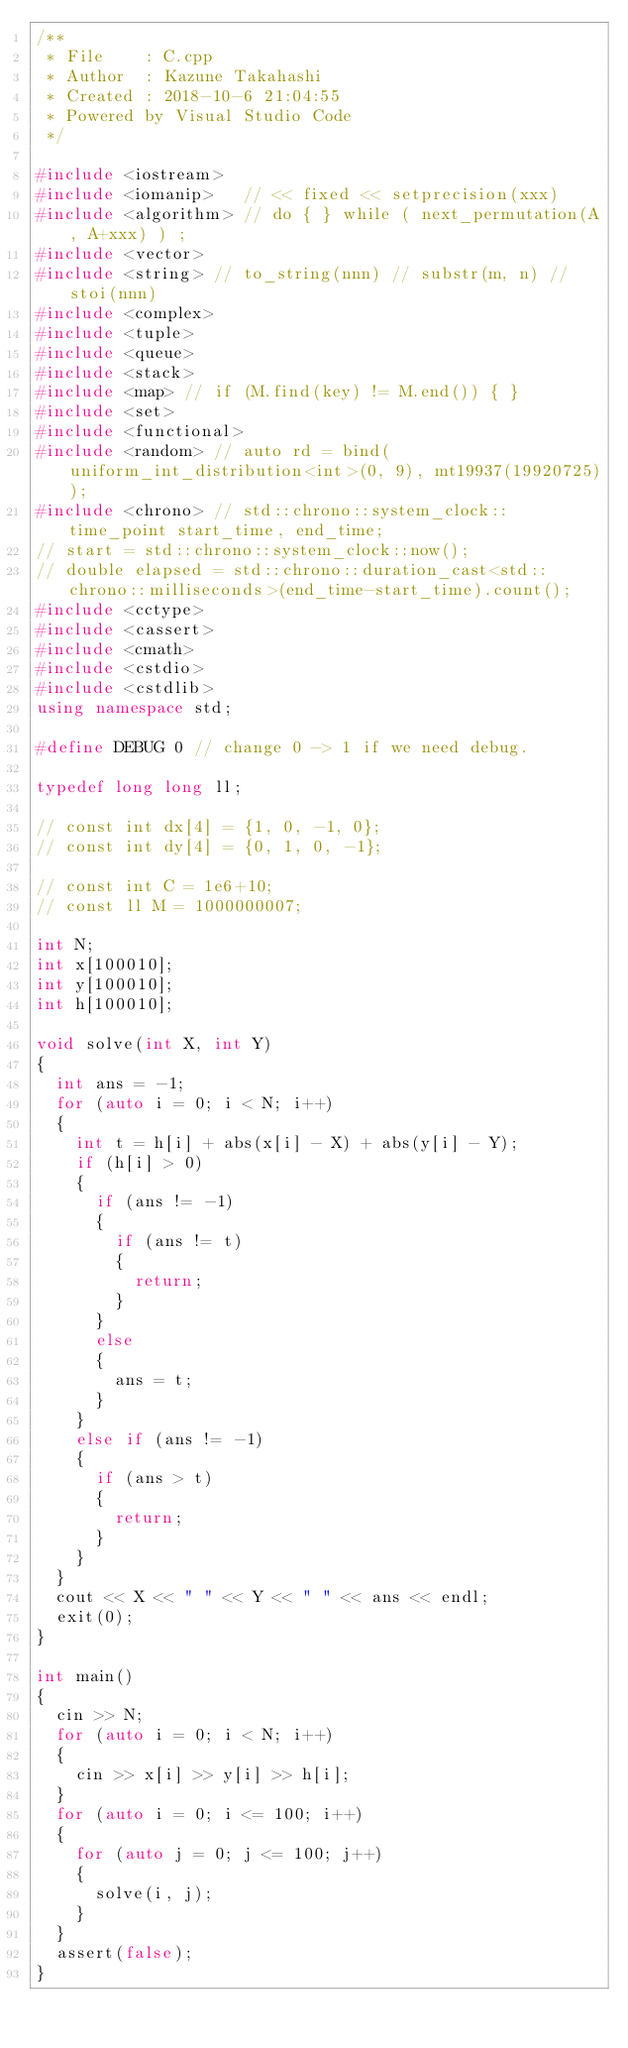Convert code to text. <code><loc_0><loc_0><loc_500><loc_500><_C++_>/**
 * File    : C.cpp
 * Author  : Kazune Takahashi
 * Created : 2018-10-6 21:04:55
 * Powered by Visual Studio Code
 */

#include <iostream>
#include <iomanip>   // << fixed << setprecision(xxx)
#include <algorithm> // do { } while ( next_permutation(A, A+xxx) ) ;
#include <vector>
#include <string> // to_string(nnn) // substr(m, n) // stoi(nnn)
#include <complex>
#include <tuple>
#include <queue>
#include <stack>
#include <map> // if (M.find(key) != M.end()) { }
#include <set>
#include <functional>
#include <random> // auto rd = bind(uniform_int_distribution<int>(0, 9), mt19937(19920725));
#include <chrono> // std::chrono::system_clock::time_point start_time, end_time;
// start = std::chrono::system_clock::now();
// double elapsed = std::chrono::duration_cast<std::chrono::milliseconds>(end_time-start_time).count();
#include <cctype>
#include <cassert>
#include <cmath>
#include <cstdio>
#include <cstdlib>
using namespace std;

#define DEBUG 0 // change 0 -> 1 if we need debug.

typedef long long ll;

// const int dx[4] = {1, 0, -1, 0};
// const int dy[4] = {0, 1, 0, -1};

// const int C = 1e6+10;
// const ll M = 1000000007;

int N;
int x[100010];
int y[100010];
int h[100010];

void solve(int X, int Y)
{
  int ans = -1;
  for (auto i = 0; i < N; i++)
  {
    int t = h[i] + abs(x[i] - X) + abs(y[i] - Y);
    if (h[i] > 0)
    {
      if (ans != -1)
      {
        if (ans != t)
        {
          return;
        }
      }
      else
      {
        ans = t;
      }
    }
    else if (ans != -1)
    {
      if (ans > t)
      {
        return;
      }
    }
  }
  cout << X << " " << Y << " " << ans << endl;
  exit(0);
}

int main()
{
  cin >> N;
  for (auto i = 0; i < N; i++)
  {
    cin >> x[i] >> y[i] >> h[i];
  }
  for (auto i = 0; i <= 100; i++)
  {
    for (auto j = 0; j <= 100; j++)
    {
      solve(i, j);
    }
  }
  assert(false);
}</code> 